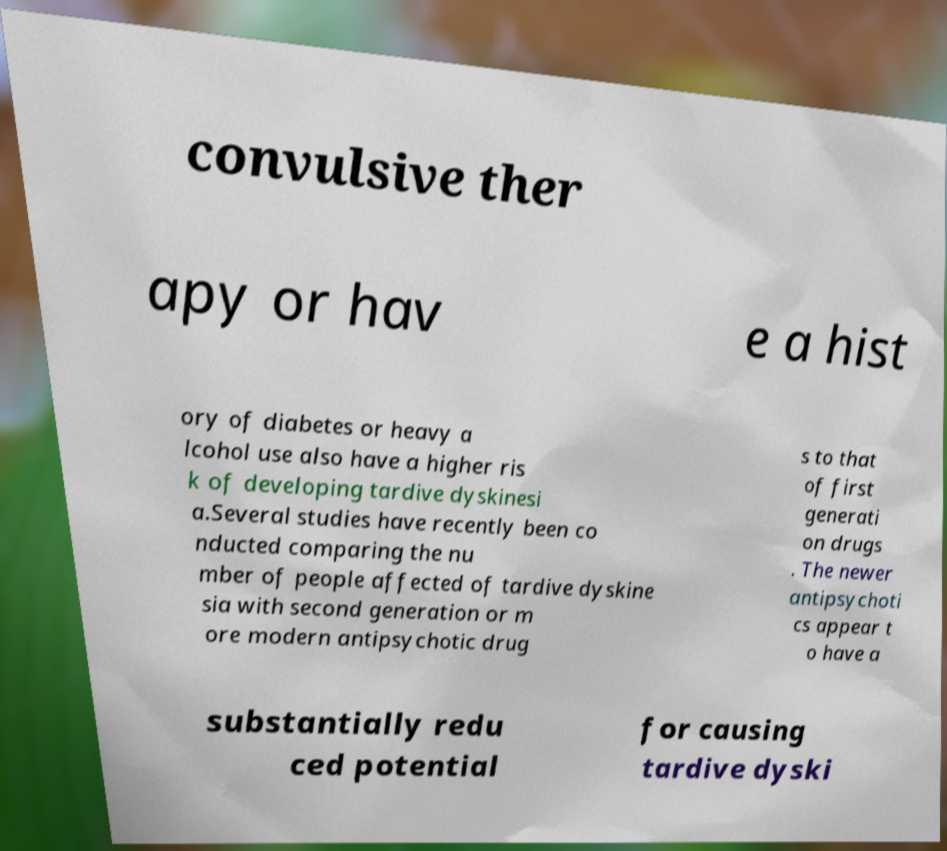What messages or text are displayed in this image? I need them in a readable, typed format. convulsive ther apy or hav e a hist ory of diabetes or heavy a lcohol use also have a higher ris k of developing tardive dyskinesi a.Several studies have recently been co nducted comparing the nu mber of people affected of tardive dyskine sia with second generation or m ore modern antipsychotic drug s to that of first generati on drugs . The newer antipsychoti cs appear t o have a substantially redu ced potential for causing tardive dyski 